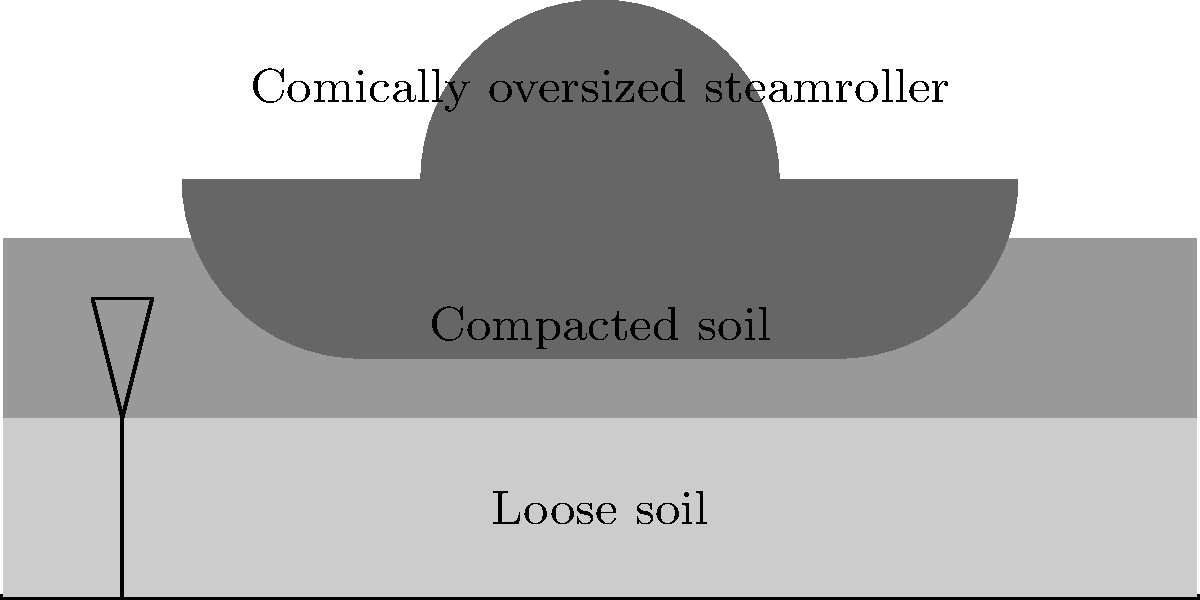In a soil compaction project using a comically oversized steamroller, the initial loose soil layer is 60 cm thick. After compaction, the layer thickness reduces to 40 cm. Calculate the relative compaction achieved, assuming the maximum dry density is 1.8 g/cm³ and the initial dry density is 1.5 g/cm³. Let's approach this step-by-step:

1. Define relative compaction:
   Relative compaction = (Field dry density / Maximum dry density) × 100%

2. Calculate the field dry density after compaction:
   - Initial volume = 60 cm (thickness) × 1 m² (unit area)
   - Final volume = 40 cm (thickness) × 1 m² (unit area)
   - Mass remains constant during compaction
   - Initial mass = Initial volume × Initial dry density
     = 60 cm × 1 m² × 1.5 g/cm³ = 90,000 g

3. Calculate field dry density after compaction:
   Field dry density = Mass / Final volume
   = 90,000 g / (40 cm × 1 m²)
   = 2.25 g/cm³

4. Calculate relative compaction:
   Relative compaction = (Field dry density / Maximum dry density) × 100%
   = (2.25 g/cm³ / 1.8 g/cm³) × 100%
   = 1.25 × 100%
   = 125%

5. Interpret the result:
   A relative compaction over 100% indicates over-compaction, which is possible in this comical scenario due to the oversized steamroller.
Answer: 125% 